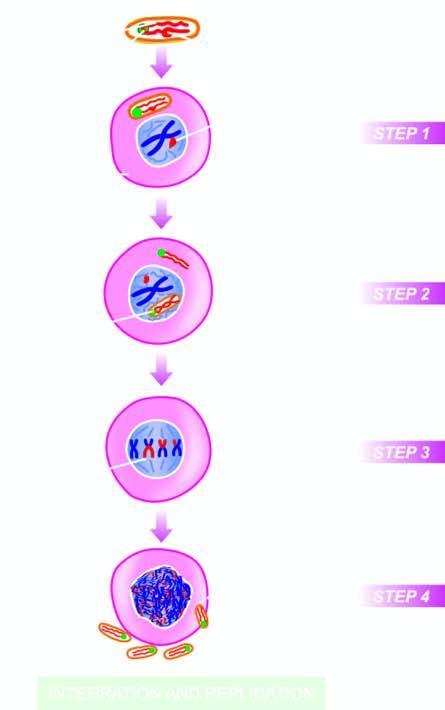how does the viral envelope fuse with?
Answer the question using a single word or phrase. The plasma membrane of the host cell 